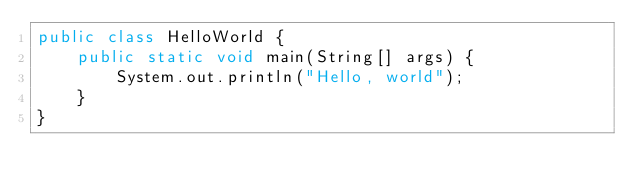Convert code to text. <code><loc_0><loc_0><loc_500><loc_500><_Java_>public class HelloWorld {
    public static void main(String[] args) {
        System.out.println("Hello, world");
    }
}
</code> 